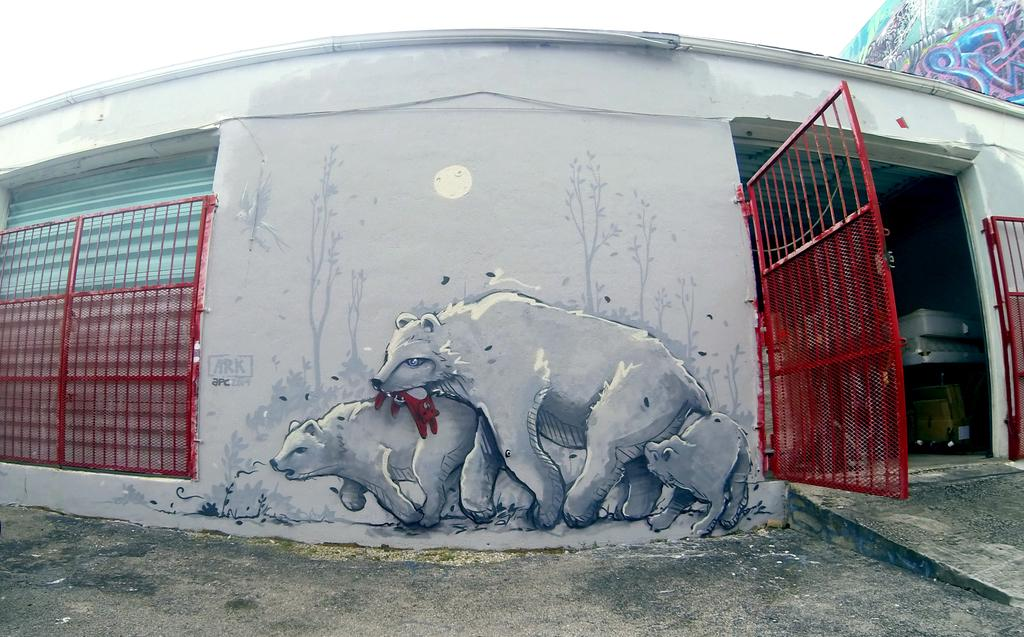What type of structure can be seen in the image? There are gates in the image. What other architectural feature is present in the image? There is a shutter in the image. What can be found on the wall in the image? There is a painting on the wall in the image. What can be seen in the background of the image? The sky is visible in the background of the image. What type of toothbrush is being used by the spy in the image? There is no toothbrush or spy present in the image. 